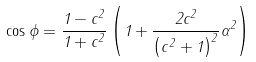Convert formula to latex. <formula><loc_0><loc_0><loc_500><loc_500>\cos \phi = \frac { 1 - c ^ { 2 } } { 1 + c ^ { 2 } } \left ( 1 + \frac { 2 c ^ { 2 } } { \left ( c ^ { 2 } + 1 \right ) ^ { 2 } } \alpha ^ { 2 } \right )</formula> 